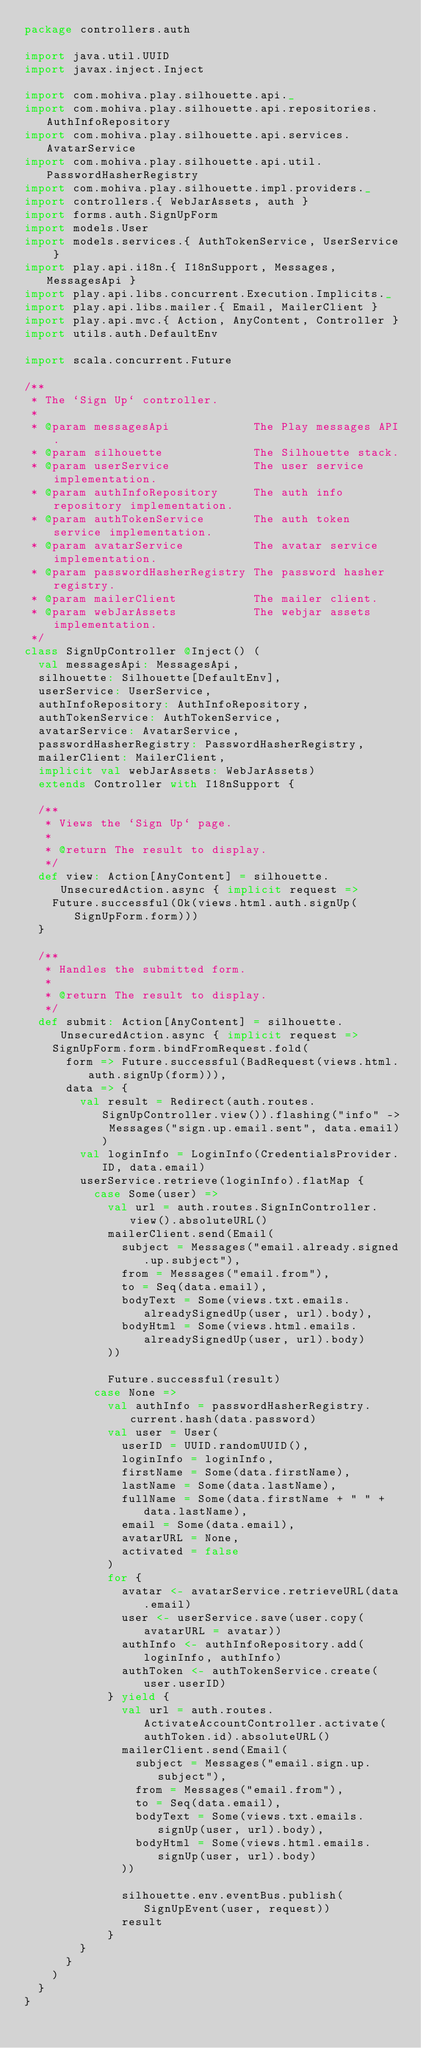Convert code to text. <code><loc_0><loc_0><loc_500><loc_500><_Scala_>package controllers.auth

import java.util.UUID
import javax.inject.Inject

import com.mohiva.play.silhouette.api._
import com.mohiva.play.silhouette.api.repositories.AuthInfoRepository
import com.mohiva.play.silhouette.api.services.AvatarService
import com.mohiva.play.silhouette.api.util.PasswordHasherRegistry
import com.mohiva.play.silhouette.impl.providers._
import controllers.{ WebJarAssets, auth }
import forms.auth.SignUpForm
import models.User
import models.services.{ AuthTokenService, UserService }
import play.api.i18n.{ I18nSupport, Messages, MessagesApi }
import play.api.libs.concurrent.Execution.Implicits._
import play.api.libs.mailer.{ Email, MailerClient }
import play.api.mvc.{ Action, AnyContent, Controller }
import utils.auth.DefaultEnv

import scala.concurrent.Future

/**
 * The `Sign Up` controller.
 *
 * @param messagesApi            The Play messages API.
 * @param silhouette             The Silhouette stack.
 * @param userService            The user service implementation.
 * @param authInfoRepository     The auth info repository implementation.
 * @param authTokenService       The auth token service implementation.
 * @param avatarService          The avatar service implementation.
 * @param passwordHasherRegistry The password hasher registry.
 * @param mailerClient           The mailer client.
 * @param webJarAssets           The webjar assets implementation.
 */
class SignUpController @Inject() (
  val messagesApi: MessagesApi,
  silhouette: Silhouette[DefaultEnv],
  userService: UserService,
  authInfoRepository: AuthInfoRepository,
  authTokenService: AuthTokenService,
  avatarService: AvatarService,
  passwordHasherRegistry: PasswordHasherRegistry,
  mailerClient: MailerClient,
  implicit val webJarAssets: WebJarAssets)
  extends Controller with I18nSupport {

  /**
   * Views the `Sign Up` page.
   *
   * @return The result to display.
   */
  def view: Action[AnyContent] = silhouette.UnsecuredAction.async { implicit request =>
    Future.successful(Ok(views.html.auth.signUp(SignUpForm.form)))
  }

  /**
   * Handles the submitted form.
   *
   * @return The result to display.
   */
  def submit: Action[AnyContent] = silhouette.UnsecuredAction.async { implicit request =>
    SignUpForm.form.bindFromRequest.fold(
      form => Future.successful(BadRequest(views.html.auth.signUp(form))),
      data => {
        val result = Redirect(auth.routes.SignUpController.view()).flashing("info" -> Messages("sign.up.email.sent", data.email))
        val loginInfo = LoginInfo(CredentialsProvider.ID, data.email)
        userService.retrieve(loginInfo).flatMap {
          case Some(user) =>
            val url = auth.routes.SignInController.view().absoluteURL()
            mailerClient.send(Email(
              subject = Messages("email.already.signed.up.subject"),
              from = Messages("email.from"),
              to = Seq(data.email),
              bodyText = Some(views.txt.emails.alreadySignedUp(user, url).body),
              bodyHtml = Some(views.html.emails.alreadySignedUp(user, url).body)
            ))

            Future.successful(result)
          case None =>
            val authInfo = passwordHasherRegistry.current.hash(data.password)
            val user = User(
              userID = UUID.randomUUID(),
              loginInfo = loginInfo,
              firstName = Some(data.firstName),
              lastName = Some(data.lastName),
              fullName = Some(data.firstName + " " + data.lastName),
              email = Some(data.email),
              avatarURL = None,
              activated = false
            )
            for {
              avatar <- avatarService.retrieveURL(data.email)
              user <- userService.save(user.copy(avatarURL = avatar))
              authInfo <- authInfoRepository.add(loginInfo, authInfo)
              authToken <- authTokenService.create(user.userID)
            } yield {
              val url = auth.routes.ActivateAccountController.activate(authToken.id).absoluteURL()
              mailerClient.send(Email(
                subject = Messages("email.sign.up.subject"),
                from = Messages("email.from"),
                to = Seq(data.email),
                bodyText = Some(views.txt.emails.signUp(user, url).body),
                bodyHtml = Some(views.html.emails.signUp(user, url).body)
              ))

              silhouette.env.eventBus.publish(SignUpEvent(user, request))
              result
            }
        }
      }
    )
  }
}
</code> 